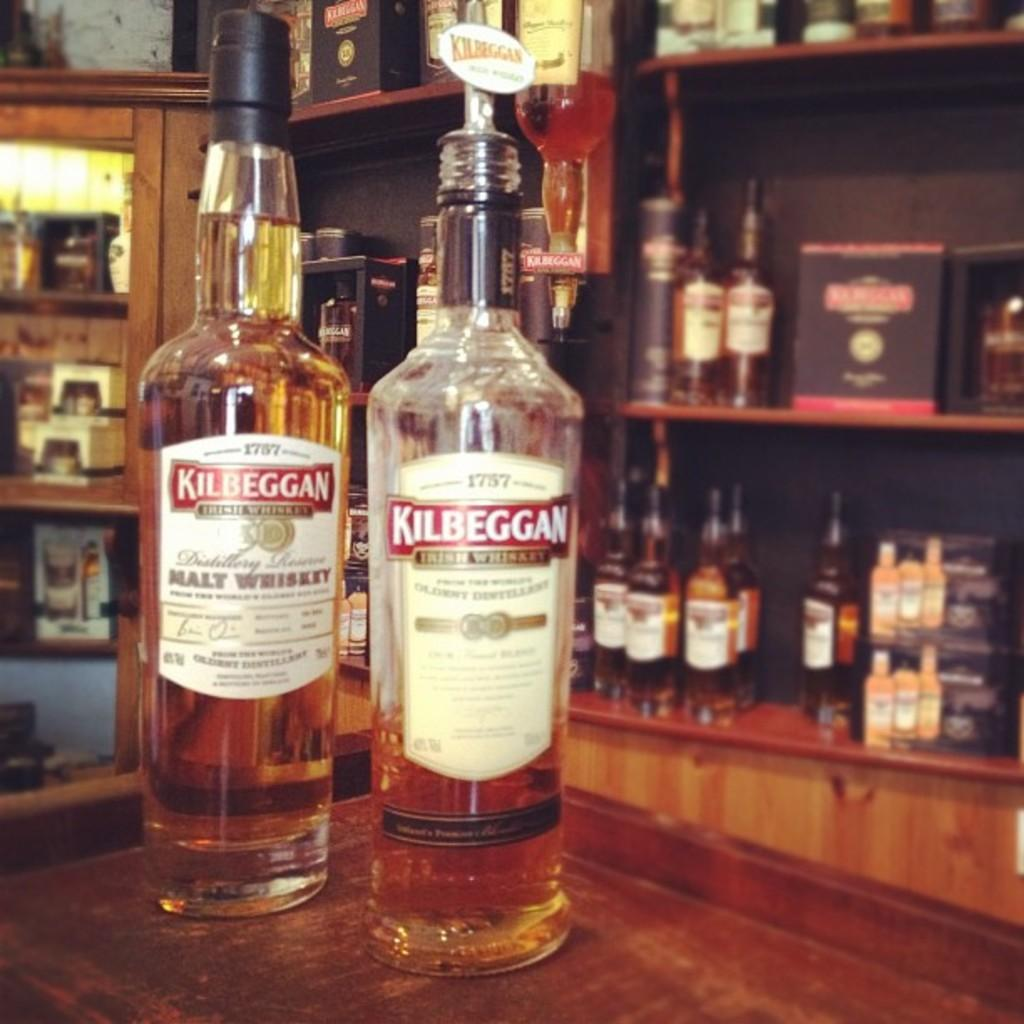<image>
Render a clear and concise summary of the photo. A bar with liquor on the back shelves and two bottles of whiskey on the bar counter. 